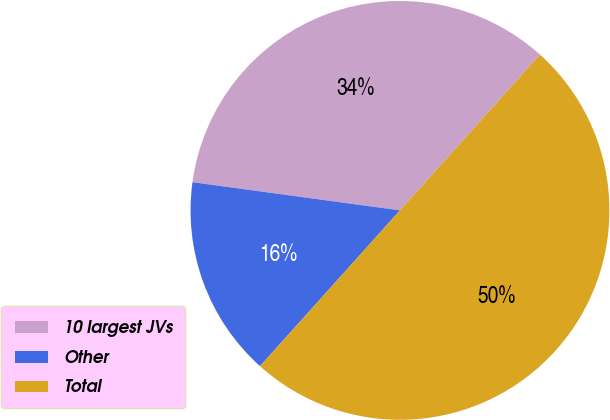Convert chart to OTSL. <chart><loc_0><loc_0><loc_500><loc_500><pie_chart><fcel>10 largest JVs<fcel>Other<fcel>Total<nl><fcel>34.5%<fcel>15.5%<fcel>50.0%<nl></chart> 